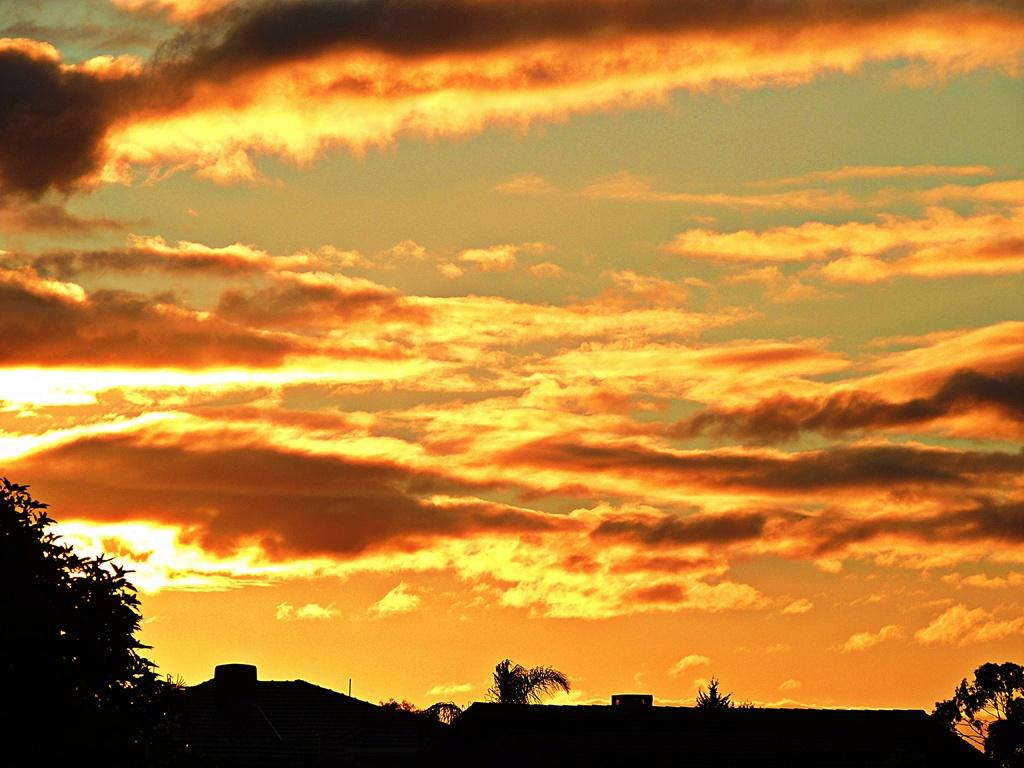What type of vegetation can be seen in the image? There are trees in the image. How would you describe the colors of the sky in the background? The sky in the background has orange, yellow, and gray colors. What is the limit of the cars in the image? There are no cars present in the image, so there is no limit to discuss. 